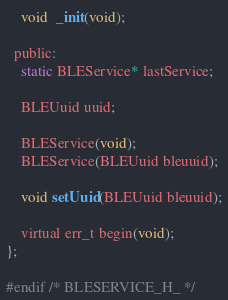Convert code to text. <code><loc_0><loc_0><loc_500><loc_500><_C_>    void  _init(void);
  
  public:
    static BLEService* lastService;

    BLEUuid uuid;

    BLEService(void);
    BLEService(BLEUuid bleuuid);

    void setUuid(BLEUuid bleuuid);

    virtual err_t begin(void);
};

#endif /* BLESERVICE_H_ */
</code> 